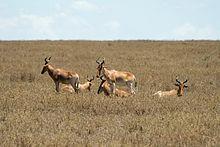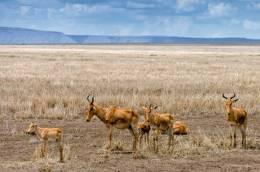The first image is the image on the left, the second image is the image on the right. For the images shown, is this caption "Left image contains one horned animal, standing with its body turned rightward." true? Answer yes or no. No. The first image is the image on the left, the second image is the image on the right. Analyze the images presented: Is the assertion "A single horned animal is standing in the grass in the image on the left." valid? Answer yes or no. No. 